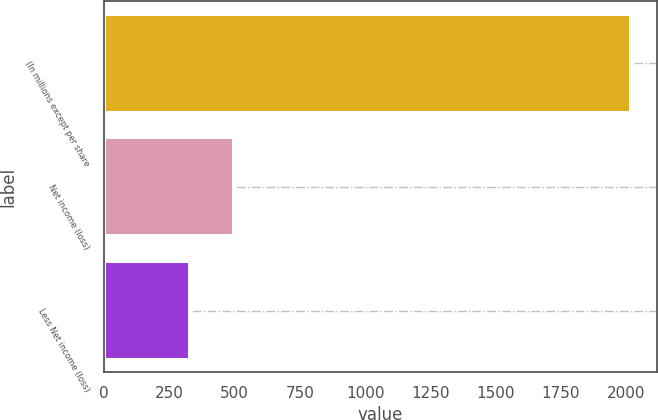<chart> <loc_0><loc_0><loc_500><loc_500><bar_chart><fcel>(In millions except per share<fcel>Net income (loss)<fcel>Less Net income (loss)<nl><fcel>2017<fcel>498.7<fcel>330<nl></chart> 